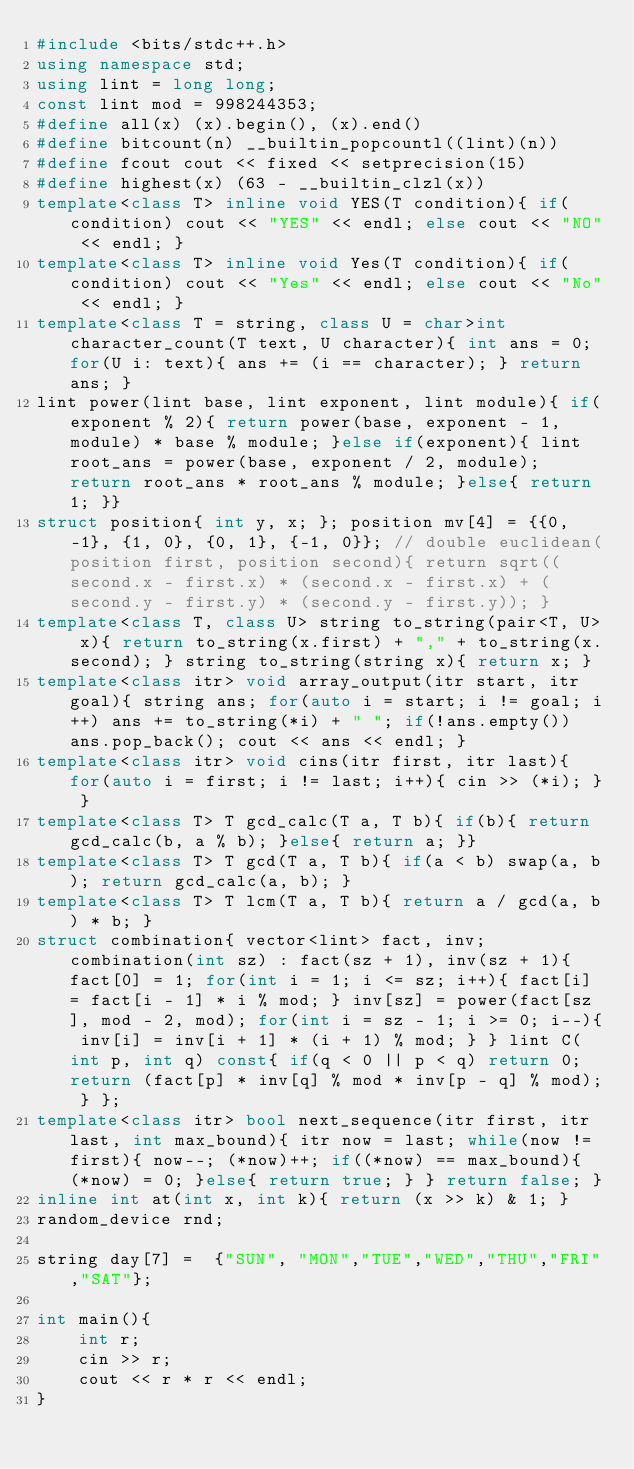<code> <loc_0><loc_0><loc_500><loc_500><_C++_>#include <bits/stdc++.h>
using namespace std;
using lint = long long;
const lint mod = 998244353;
#define all(x) (x).begin(), (x).end()
#define bitcount(n) __builtin_popcountl((lint)(n))
#define fcout cout << fixed << setprecision(15)
#define highest(x) (63 - __builtin_clzl(x))
template<class T> inline void YES(T condition){ if(condition) cout << "YES" << endl; else cout << "NO" << endl; }
template<class T> inline void Yes(T condition){ if(condition) cout << "Yes" << endl; else cout << "No" << endl; }
template<class T = string, class U = char>int character_count(T text, U character){ int ans = 0; for(U i: text){ ans += (i == character); } return ans; }
lint power(lint base, lint exponent, lint module){ if(exponent % 2){ return power(base, exponent - 1, module) * base % module; }else if(exponent){ lint root_ans = power(base, exponent / 2, module); return root_ans * root_ans % module; }else{ return 1; }}
struct position{ int y, x; }; position mv[4] = {{0, -1}, {1, 0}, {0, 1}, {-1, 0}}; // double euclidean(position first, position second){ return sqrt((second.x - first.x) * (second.x - first.x) + (second.y - first.y) * (second.y - first.y)); }
template<class T, class U> string to_string(pair<T, U> x){ return to_string(x.first) + "," + to_string(x.second); } string to_string(string x){ return x; }
template<class itr> void array_output(itr start, itr goal){ string ans; for(auto i = start; i != goal; i++) ans += to_string(*i) + " "; if(!ans.empty()) ans.pop_back(); cout << ans << endl; }
template<class itr> void cins(itr first, itr last){ for(auto i = first; i != last; i++){ cin >> (*i); } }
template<class T> T gcd_calc(T a, T b){ if(b){ return gcd_calc(b, a % b); }else{ return a; }}
template<class T> T gcd(T a, T b){ if(a < b) swap(a, b); return gcd_calc(a, b); }
template<class T> T lcm(T a, T b){ return a / gcd(a, b) * b; }
struct combination{ vector<lint> fact, inv; combination(int sz) : fact(sz + 1), inv(sz + 1){ fact[0] = 1; for(int i = 1; i <= sz; i++){ fact[i] = fact[i - 1] * i % mod; } inv[sz] = power(fact[sz], mod - 2, mod); for(int i = sz - 1; i >= 0; i--){ inv[i] = inv[i + 1] * (i + 1) % mod; } } lint C(int p, int q) const{ if(q < 0 || p < q) return 0; return (fact[p] * inv[q] % mod * inv[p - q] % mod); } };
template<class itr> bool next_sequence(itr first, itr last, int max_bound){ itr now = last; while(now != first){ now--; (*now)++; if((*now) == max_bound){ (*now) = 0; }else{ return true; } } return false; }
inline int at(int x, int k){ return (x >> k) & 1; }
random_device rnd;

string day[7] =  {"SUN", "MON","TUE","WED","THU","FRI","SAT"};

int main(){
    int r;
    cin >> r;
    cout << r * r << endl;
}
</code> 